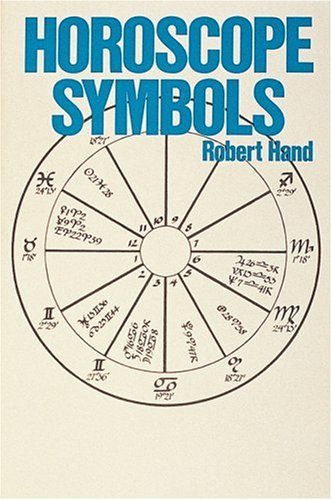Can you explain the significance of any symbol seen on the cover of the book? Certainly! The cover includes various astrological symbols, such as those for Aries, Taurus, and Gemini. Each symbol represents a zodiac sign, which in astrology, correspond to particular personality traits, tendencies, and possible life events. 